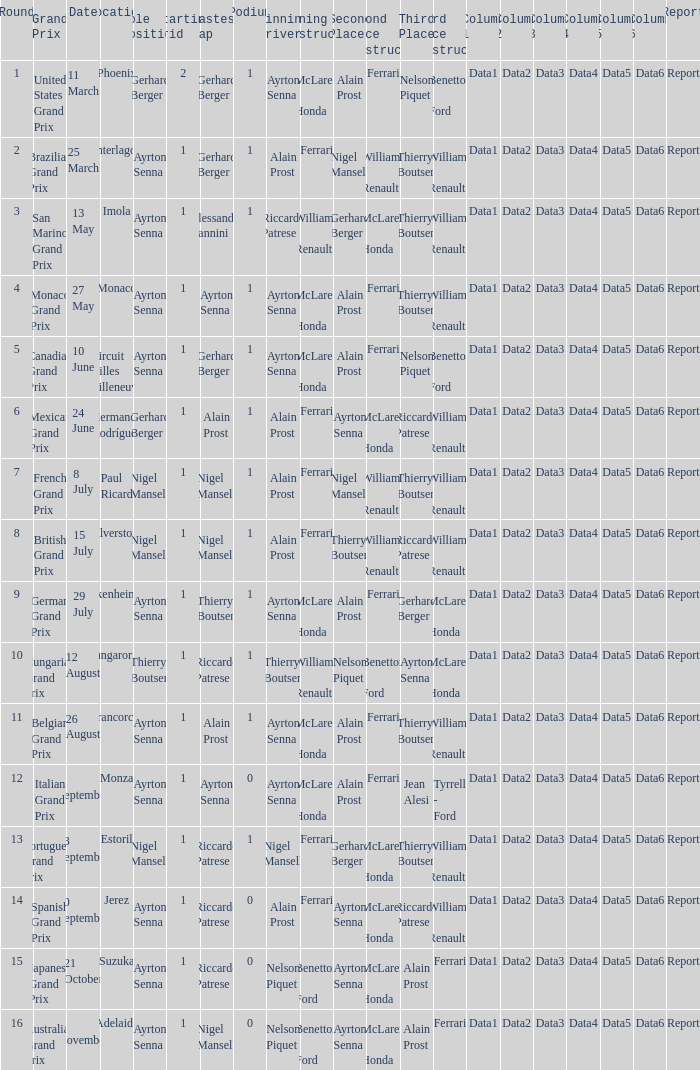What was the constructor when riccardo patrese was the winning driver? Williams - Renault. 